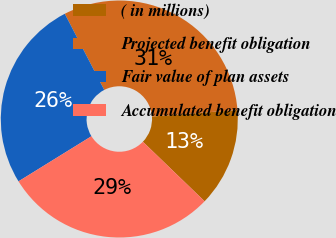<chart> <loc_0><loc_0><loc_500><loc_500><pie_chart><fcel>( in millions)<fcel>Projected benefit obligation<fcel>Fair value of plan assets<fcel>Accumulated benefit obligation<nl><fcel>13.42%<fcel>31.4%<fcel>26.21%<fcel>28.97%<nl></chart> 